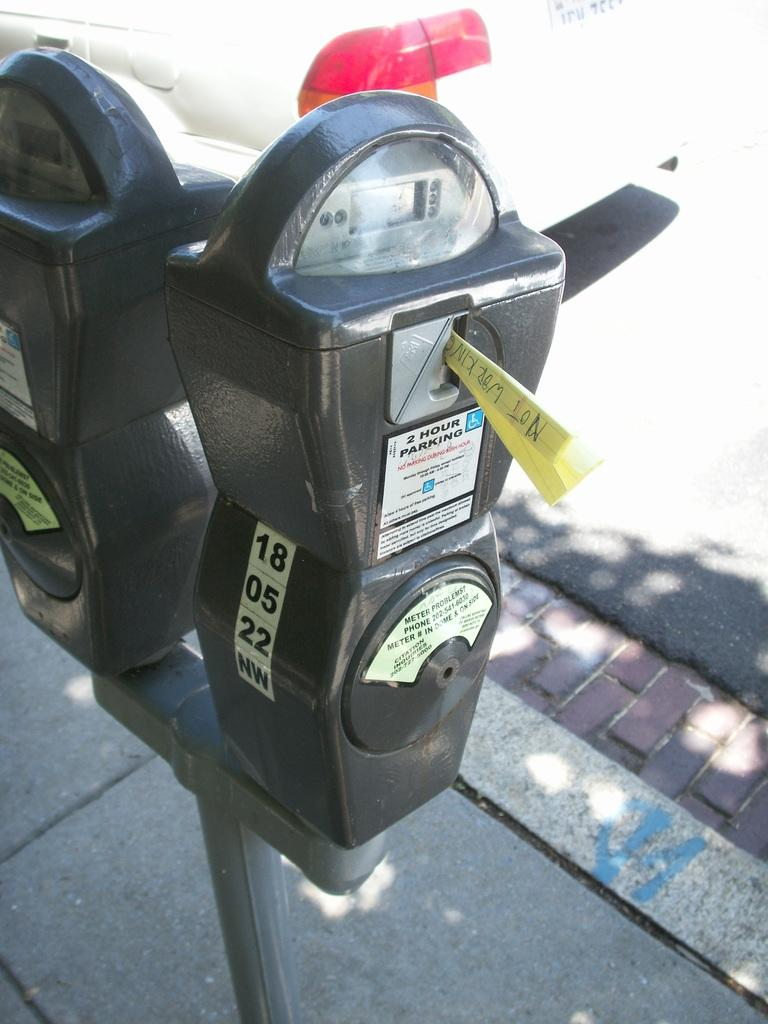What objects can be seen in the image related to parking? There are two parking meters in the image. Where are the parking meters located in relation to the road? The parking meters are beside the road. What time of day is it in the image, given the presence of a star? There is no star present in the image, so we cannot determine the time of day based on that information. 